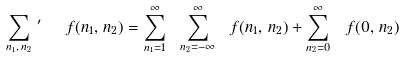<formula> <loc_0><loc_0><loc_500><loc_500>\sum _ { n _ { 1 } , \, n _ { 2 } } \, ^ { \prime } \ \ f ( n _ { 1 } , \, n _ { 2 } ) = \sum _ { n _ { 1 } = 1 } ^ { \infty } \ \sum _ { n _ { 2 } = - \infty } ^ { \infty } \ f ( n _ { 1 } , \, n _ { 2 } ) + \sum _ { n _ { 2 } = 0 } ^ { \infty } \ f ( 0 , \, n _ { 2 } )</formula> 